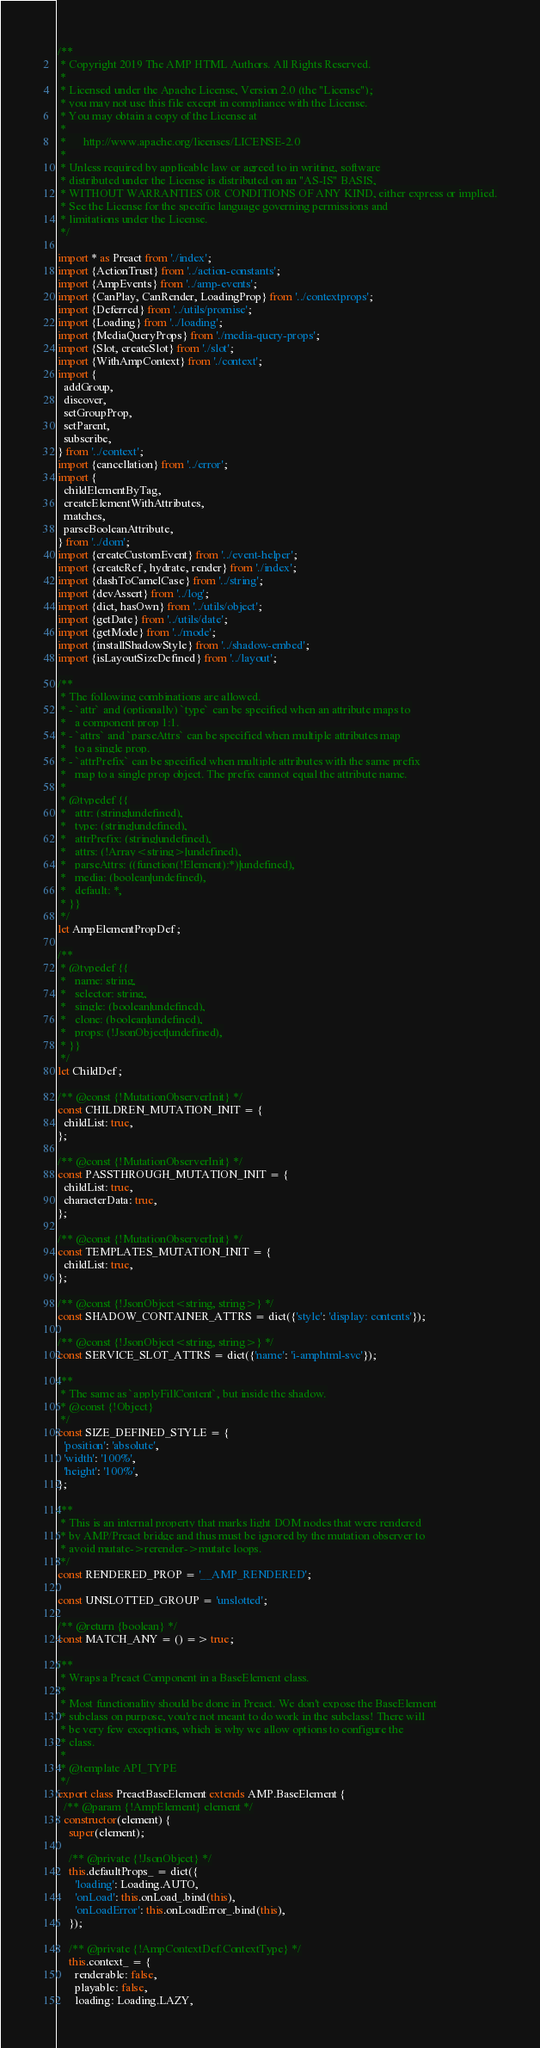Convert code to text. <code><loc_0><loc_0><loc_500><loc_500><_JavaScript_>/**
 * Copyright 2019 The AMP HTML Authors. All Rights Reserved.
 *
 * Licensed under the Apache License, Version 2.0 (the "License");
 * you may not use this file except in compliance with the License.
 * You may obtain a copy of the License at
 *
 *      http://www.apache.org/licenses/LICENSE-2.0
 *
 * Unless required by applicable law or agreed to in writing, software
 * distributed under the License is distributed on an "AS-IS" BASIS,
 * WITHOUT WARRANTIES OR CONDITIONS OF ANY KIND, either express or implied.
 * See the License for the specific language governing permissions and
 * limitations under the License.
 */

import * as Preact from './index';
import {ActionTrust} from '../action-constants';
import {AmpEvents} from '../amp-events';
import {CanPlay, CanRender, LoadingProp} from '../contextprops';
import {Deferred} from '../utils/promise';
import {Loading} from '../loading';
import {MediaQueryProps} from './media-query-props';
import {Slot, createSlot} from './slot';
import {WithAmpContext} from './context';
import {
  addGroup,
  discover,
  setGroupProp,
  setParent,
  subscribe,
} from '../context';
import {cancellation} from '../error';
import {
  childElementByTag,
  createElementWithAttributes,
  matches,
  parseBooleanAttribute,
} from '../dom';
import {createCustomEvent} from '../event-helper';
import {createRef, hydrate, render} from './index';
import {dashToCamelCase} from '../string';
import {devAssert} from '../log';
import {dict, hasOwn} from '../utils/object';
import {getDate} from '../utils/date';
import {getMode} from '../mode';
import {installShadowStyle} from '../shadow-embed';
import {isLayoutSizeDefined} from '../layout';

/**
 * The following combinations are allowed.
 * - `attr` and (optionally) `type` can be specified when an attribute maps to
 *   a component prop 1:1.
 * - `attrs` and `parseAttrs` can be specified when multiple attributes map
 *   to a single prop.
 * - `attrPrefix` can be specified when multiple attributes with the same prefix
 *   map to a single prop object. The prefix cannot equal the attribute name.
 *
 * @typedef {{
 *   attr: (string|undefined),
 *   type: (string|undefined),
 *   attrPrefix: (string|undefined),
 *   attrs: (!Array<string>|undefined),
 *   parseAttrs: ((function(!Element):*)|undefined),
 *   media: (boolean|undefined),
 *   default: *,
 * }}
 */
let AmpElementPropDef;

/**
 * @typedef {{
 *   name: string,
 *   selector: string,
 *   single: (boolean|undefined),
 *   clone: (boolean|undefined),
 *   props: (!JsonObject|undefined),
 * }}
 */
let ChildDef;

/** @const {!MutationObserverInit} */
const CHILDREN_MUTATION_INIT = {
  childList: true,
};

/** @const {!MutationObserverInit} */
const PASSTHROUGH_MUTATION_INIT = {
  childList: true,
  characterData: true,
};

/** @const {!MutationObserverInit} */
const TEMPLATES_MUTATION_INIT = {
  childList: true,
};

/** @const {!JsonObject<string, string>} */
const SHADOW_CONTAINER_ATTRS = dict({'style': 'display: contents'});

/** @const {!JsonObject<string, string>} */
const SERVICE_SLOT_ATTRS = dict({'name': 'i-amphtml-svc'});

/**
 * The same as `applyFillContent`, but inside the shadow.
 * @const {!Object}
 */
const SIZE_DEFINED_STYLE = {
  'position': 'absolute',
  'width': '100%',
  'height': '100%',
};

/**
 * This is an internal property that marks light DOM nodes that were rendered
 * by AMP/Preact bridge and thus must be ignored by the mutation observer to
 * avoid mutate->rerender->mutate loops.
 */
const RENDERED_PROP = '__AMP_RENDERED';

const UNSLOTTED_GROUP = 'unslotted';

/** @return {boolean} */
const MATCH_ANY = () => true;

/**
 * Wraps a Preact Component in a BaseElement class.
 *
 * Most functionality should be done in Preact. We don't expose the BaseElement
 * subclass on purpose, you're not meant to do work in the subclass! There will
 * be very few exceptions, which is why we allow options to configure the
 * class.
 *
 * @template API_TYPE
 */
export class PreactBaseElement extends AMP.BaseElement {
  /** @param {!AmpElement} element */
  constructor(element) {
    super(element);

    /** @private {!JsonObject} */
    this.defaultProps_ = dict({
      'loading': Loading.AUTO,
      'onLoad': this.onLoad_.bind(this),
      'onLoadError': this.onLoadError_.bind(this),
    });

    /** @private {!AmpContextDef.ContextType} */
    this.context_ = {
      renderable: false,
      playable: false,
      loading: Loading.LAZY,</code> 